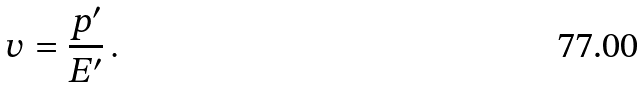Convert formula to latex. <formula><loc_0><loc_0><loc_500><loc_500>v = \frac { p ^ { \prime } } { E ^ { \prime } } \, .</formula> 